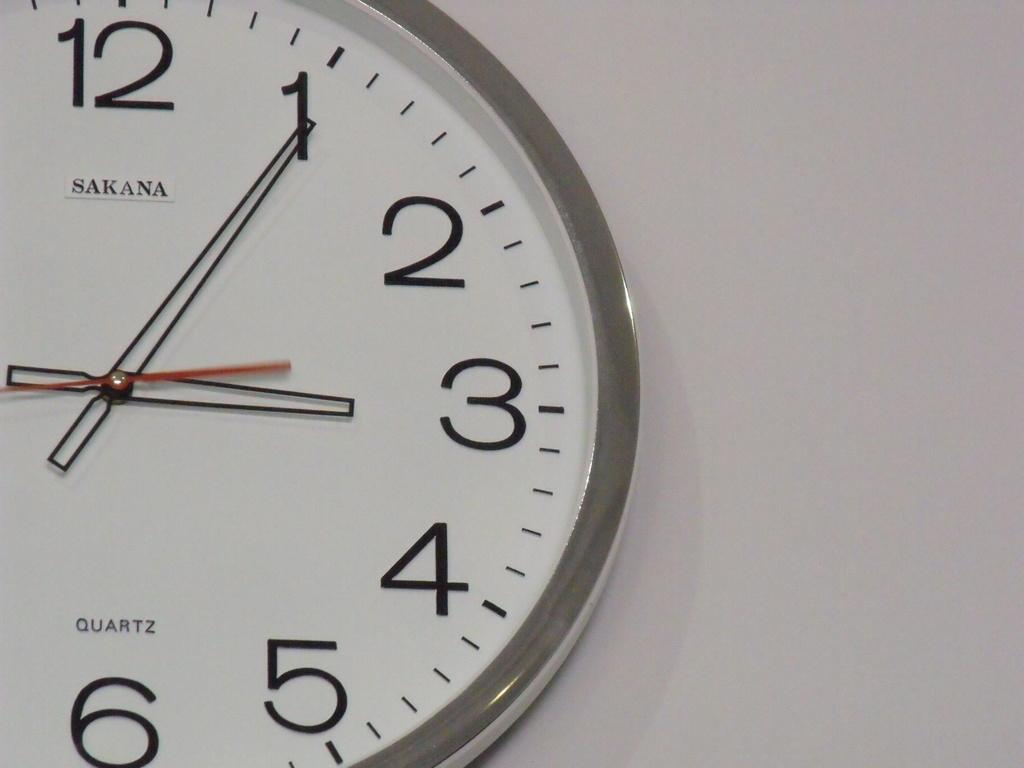Provide a one-sentence caption for the provided image. a clock that has the number 12 on it. 